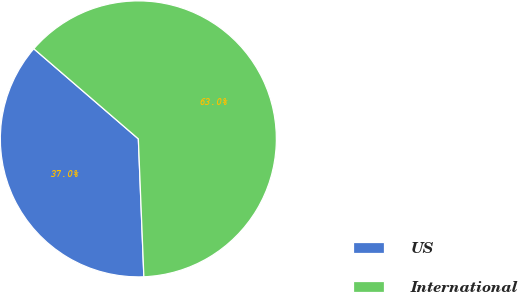<chart> <loc_0><loc_0><loc_500><loc_500><pie_chart><fcel>US<fcel>International<nl><fcel>36.96%<fcel>63.04%<nl></chart> 